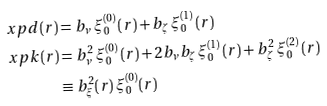Convert formula to latex. <formula><loc_0><loc_0><loc_500><loc_500>\ x p d ( r ) & = b _ { \nu } \, \xi _ { 0 } ^ { ( 0 ) } \, ( r ) + b _ { \zeta } \, \xi _ { 0 } ^ { ( 1 ) } \, ( r ) \, \\ \ x p k ( r ) & = b _ { \nu } ^ { 2 } \, \xi _ { 0 } ^ { ( 0 ) } \, ( r ) + 2 b _ { \nu } b _ { \zeta } \, \xi _ { 0 } ^ { ( 1 ) } \, ( r ) + b _ { \zeta } ^ { 2 } \, \xi _ { 0 } ^ { ( 2 ) } \, ( r ) \, \\ & \equiv b _ { \xi } ^ { 2 } ( r ) \, \xi _ { 0 } ^ { ( 0 ) } ( r )</formula> 